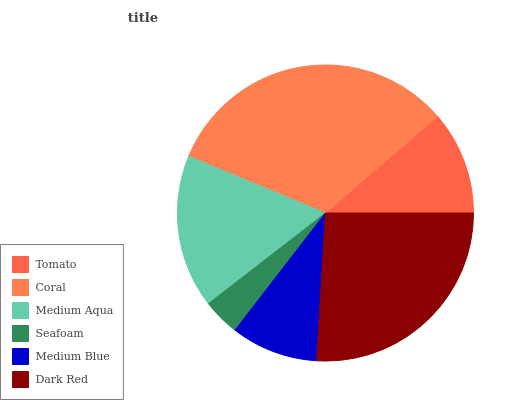Is Seafoam the minimum?
Answer yes or no. Yes. Is Coral the maximum?
Answer yes or no. Yes. Is Medium Aqua the minimum?
Answer yes or no. No. Is Medium Aqua the maximum?
Answer yes or no. No. Is Coral greater than Medium Aqua?
Answer yes or no. Yes. Is Medium Aqua less than Coral?
Answer yes or no. Yes. Is Medium Aqua greater than Coral?
Answer yes or no. No. Is Coral less than Medium Aqua?
Answer yes or no. No. Is Medium Aqua the high median?
Answer yes or no. Yes. Is Tomato the low median?
Answer yes or no. Yes. Is Coral the high median?
Answer yes or no. No. Is Seafoam the low median?
Answer yes or no. No. 